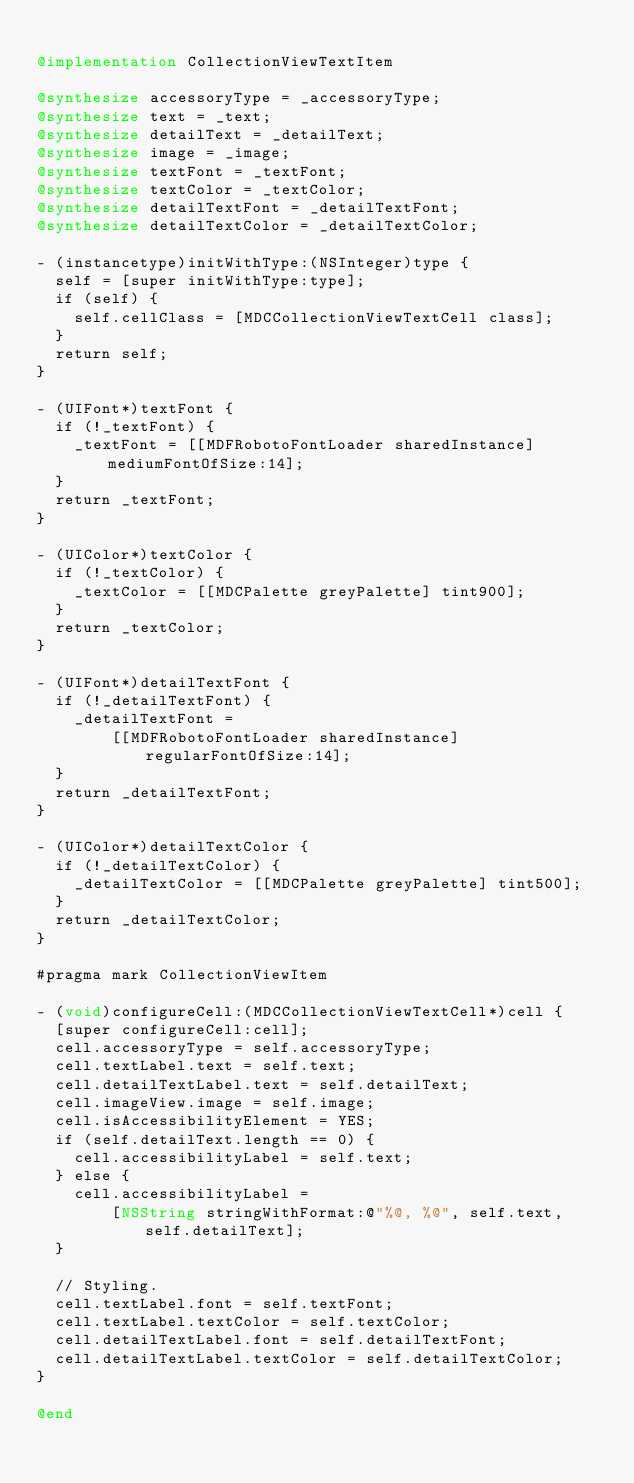Convert code to text. <code><loc_0><loc_0><loc_500><loc_500><_ObjectiveC_>
@implementation CollectionViewTextItem

@synthesize accessoryType = _accessoryType;
@synthesize text = _text;
@synthesize detailText = _detailText;
@synthesize image = _image;
@synthesize textFont = _textFont;
@synthesize textColor = _textColor;
@synthesize detailTextFont = _detailTextFont;
@synthesize detailTextColor = _detailTextColor;

- (instancetype)initWithType:(NSInteger)type {
  self = [super initWithType:type];
  if (self) {
    self.cellClass = [MDCCollectionViewTextCell class];
  }
  return self;
}

- (UIFont*)textFont {
  if (!_textFont) {
    _textFont = [[MDFRobotoFontLoader sharedInstance] mediumFontOfSize:14];
  }
  return _textFont;
}

- (UIColor*)textColor {
  if (!_textColor) {
    _textColor = [[MDCPalette greyPalette] tint900];
  }
  return _textColor;
}

- (UIFont*)detailTextFont {
  if (!_detailTextFont) {
    _detailTextFont =
        [[MDFRobotoFontLoader sharedInstance] regularFontOfSize:14];
  }
  return _detailTextFont;
}

- (UIColor*)detailTextColor {
  if (!_detailTextColor) {
    _detailTextColor = [[MDCPalette greyPalette] tint500];
  }
  return _detailTextColor;
}

#pragma mark CollectionViewItem

- (void)configureCell:(MDCCollectionViewTextCell*)cell {
  [super configureCell:cell];
  cell.accessoryType = self.accessoryType;
  cell.textLabel.text = self.text;
  cell.detailTextLabel.text = self.detailText;
  cell.imageView.image = self.image;
  cell.isAccessibilityElement = YES;
  if (self.detailText.length == 0) {
    cell.accessibilityLabel = self.text;
  } else {
    cell.accessibilityLabel =
        [NSString stringWithFormat:@"%@, %@", self.text, self.detailText];
  }

  // Styling.
  cell.textLabel.font = self.textFont;
  cell.textLabel.textColor = self.textColor;
  cell.detailTextLabel.font = self.detailTextFont;
  cell.detailTextLabel.textColor = self.detailTextColor;
}

@end
</code> 